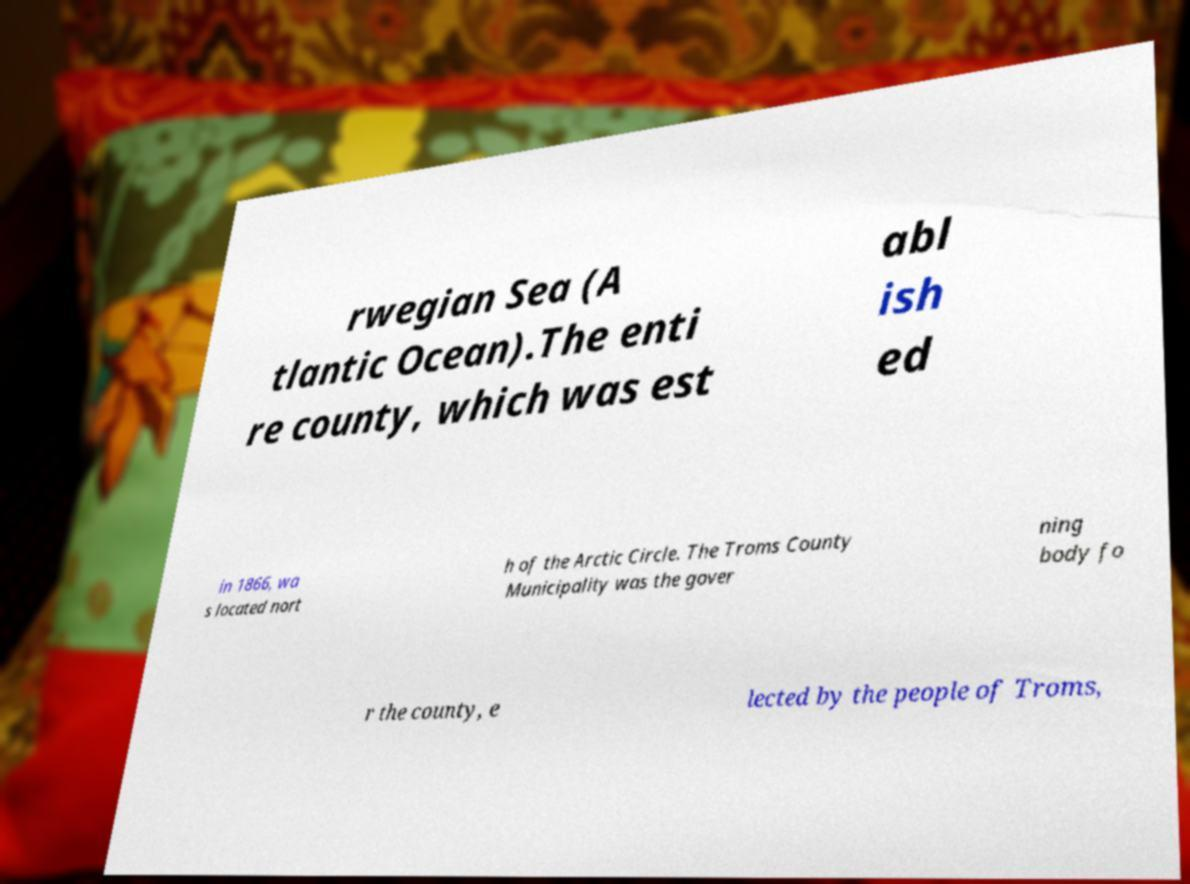I need the written content from this picture converted into text. Can you do that? rwegian Sea (A tlantic Ocean).The enti re county, which was est abl ish ed in 1866, wa s located nort h of the Arctic Circle. The Troms County Municipality was the gover ning body fo r the county, e lected by the people of Troms, 